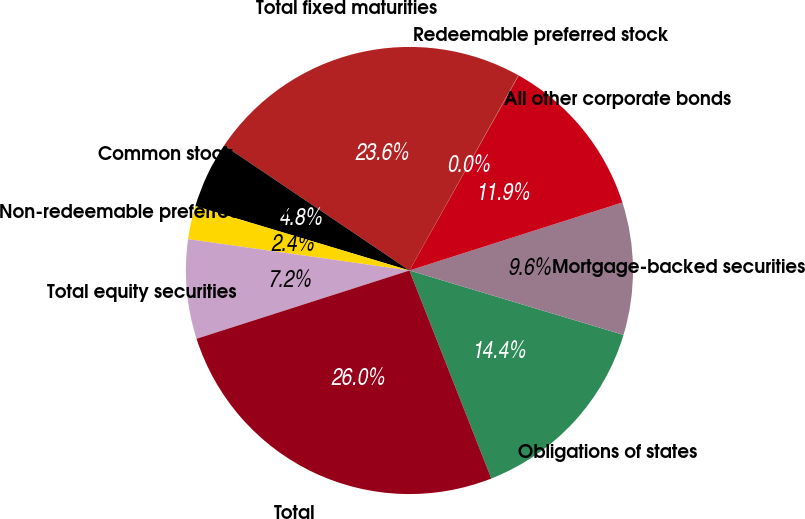Convert chart to OTSL. <chart><loc_0><loc_0><loc_500><loc_500><pie_chart><fcel>Obligations of states<fcel>Mortgage-backed securities<fcel>All other corporate bonds<fcel>Redeemable preferred stock<fcel>Total fixed maturities<fcel>Common stock<fcel>Non-redeemable preferred stock<fcel>Total equity securities<fcel>Total<nl><fcel>14.38%<fcel>9.57%<fcel>11.95%<fcel>0.03%<fcel>23.65%<fcel>4.8%<fcel>2.41%<fcel>7.18%<fcel>26.03%<nl></chart> 